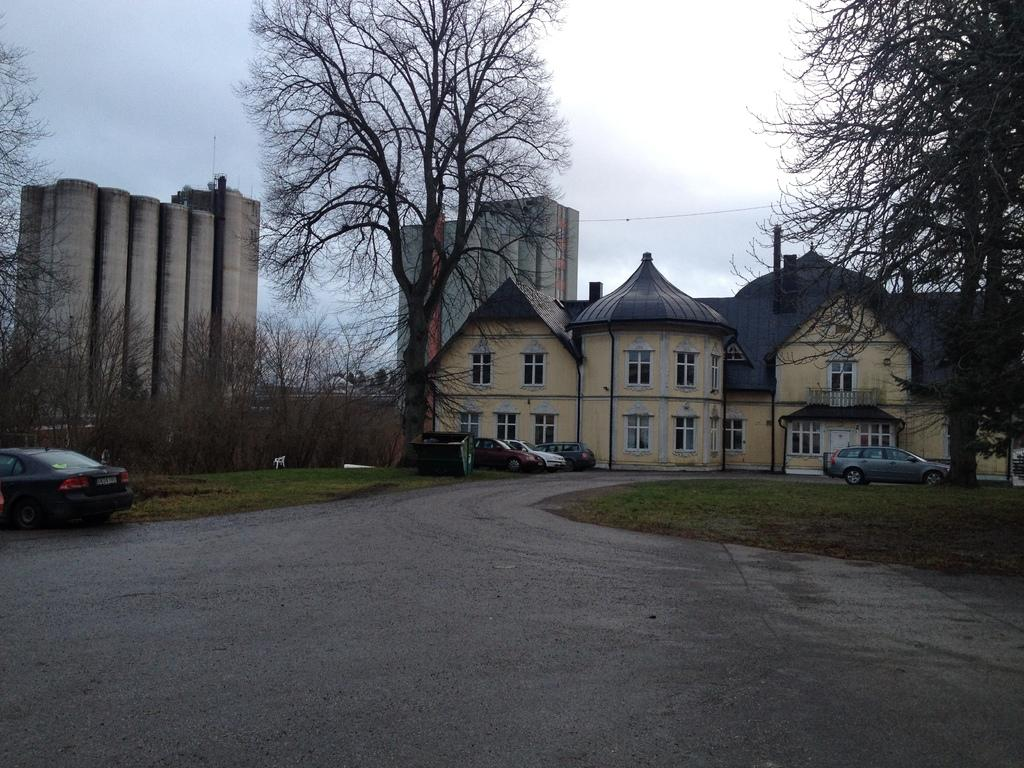What type of structure is visible in the image? There is a building with windows in the image. What else can be seen in the image besides the building? There are vehicles, trees, and pillars visible in the image. What is visible in the background of the image? The sky is visible in the image. Can you tell me how many farmers are picking berries in the image? There are no farmers or berries present in the image. 